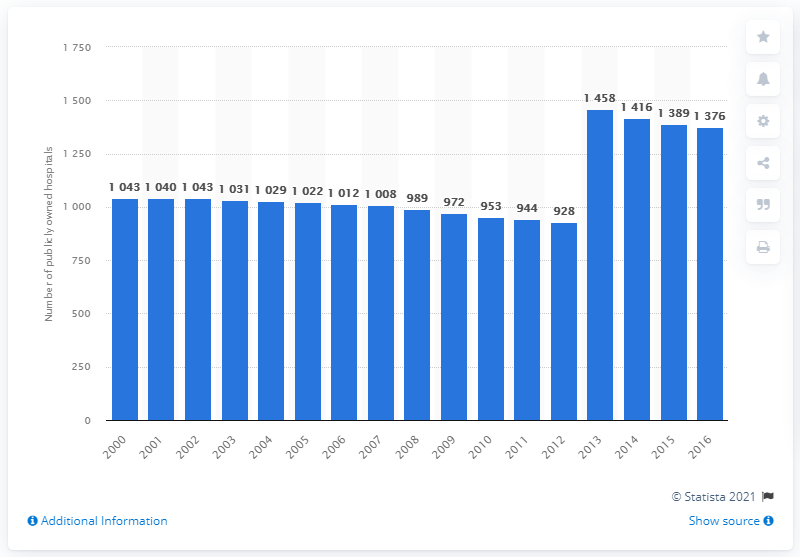Identify some key points in this picture. In the year 2013, there were 1,458 publicly owned hospitals in France. 